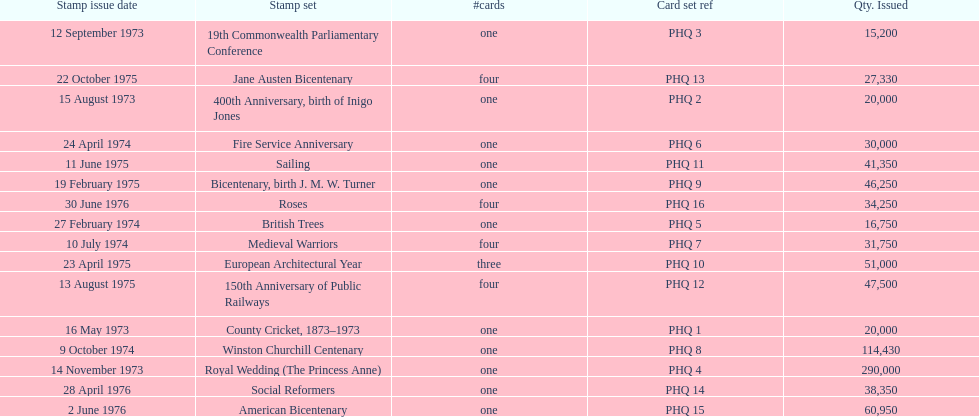Which stamp set had only three cards in the set? European Architectural Year. 